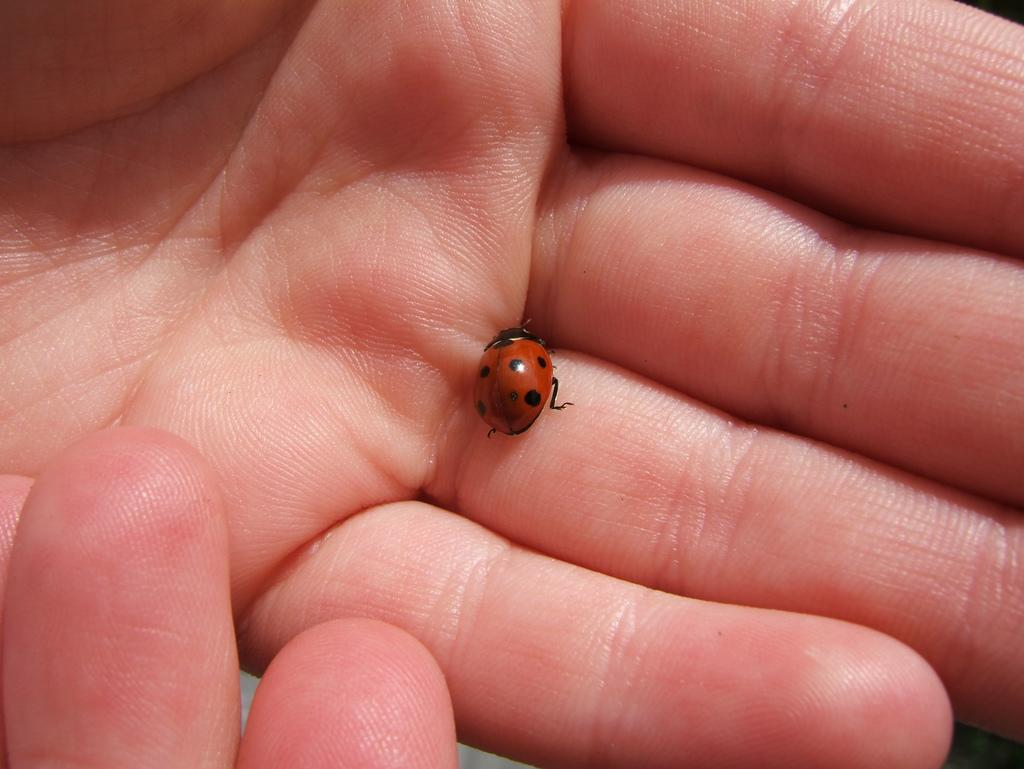What is the main subject of the image? The main subject of the image is a bug. Where is the bug located in the image? The bug is in someone's hand. What type of plants can be seen growing from the seat in the image? There is no seat or plants present in the image; it features a bug in someone's hand. 